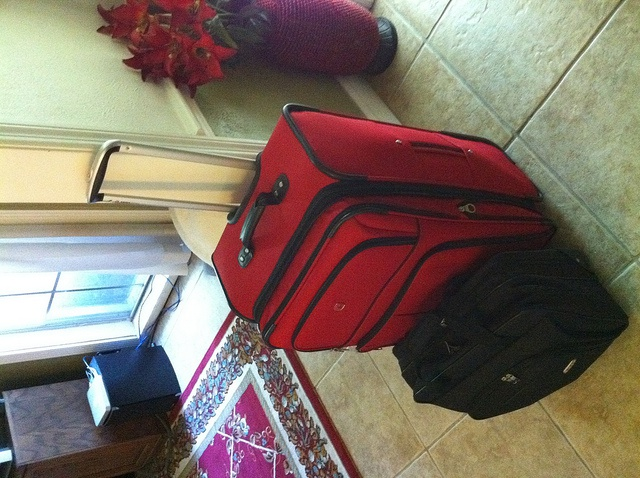Describe the objects in this image and their specific colors. I can see suitcase in tan, maroon, brown, black, and gray tones, suitcase in tan, black, olive, and gray tones, and vase in tan, black, purple, and gray tones in this image. 